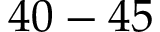Convert formula to latex. <formula><loc_0><loc_0><loc_500><loc_500>4 0 - 4 5</formula> 